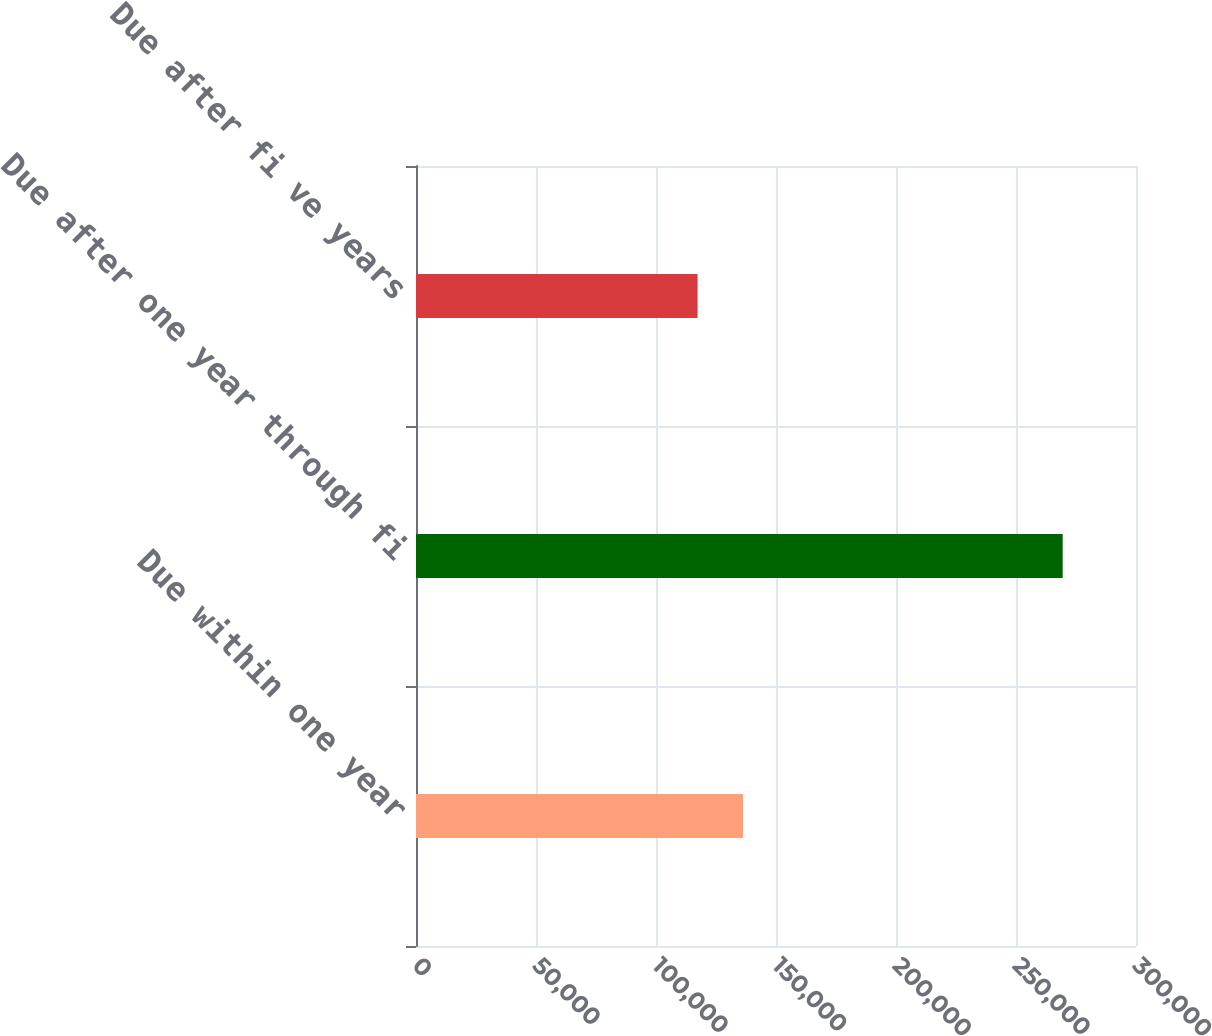Convert chart to OTSL. <chart><loc_0><loc_0><loc_500><loc_500><bar_chart><fcel>Due within one year<fcel>Due after one year through fi<fcel>Due after fi ve years<nl><fcel>136268<fcel>269450<fcel>117333<nl></chart> 